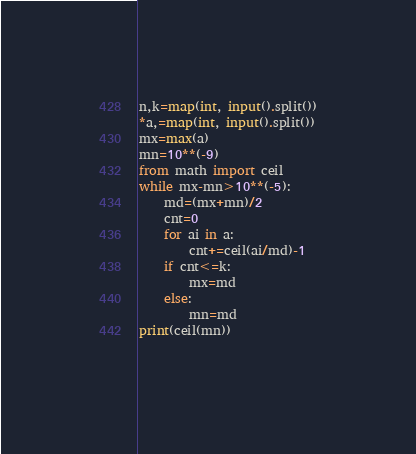<code> <loc_0><loc_0><loc_500><loc_500><_Python_>n,k=map(int, input().split())
*a,=map(int, input().split())
mx=max(a)
mn=10**(-9)
from math import ceil
while mx-mn>10**(-5):
    md=(mx+mn)/2
    cnt=0
    for ai in a:
        cnt+=ceil(ai/md)-1
    if cnt<=k:
        mx=md
    else:
        mn=md
print(ceil(mn))
    </code> 